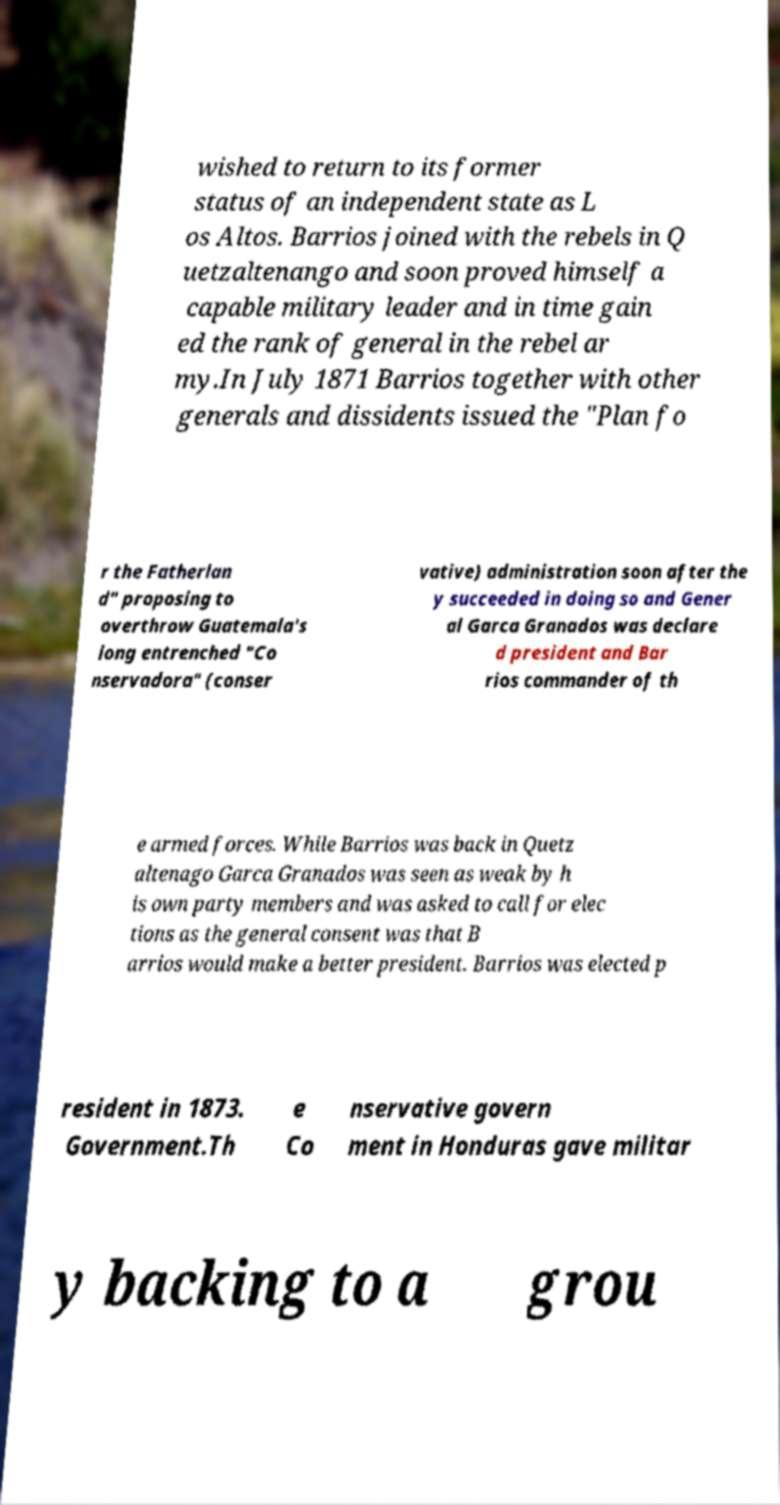Could you extract and type out the text from this image? wished to return to its former status of an independent state as L os Altos. Barrios joined with the rebels in Q uetzaltenango and soon proved himself a capable military leader and in time gain ed the rank of general in the rebel ar my.In July 1871 Barrios together with other generals and dissidents issued the "Plan fo r the Fatherlan d" proposing to overthrow Guatemala's long entrenched "Co nservadora" (conser vative) administration soon after the y succeeded in doing so and Gener al Garca Granados was declare d president and Bar rios commander of th e armed forces. While Barrios was back in Quetz altenago Garca Granados was seen as weak by h is own party members and was asked to call for elec tions as the general consent was that B arrios would make a better president. Barrios was elected p resident in 1873. Government.Th e Co nservative govern ment in Honduras gave militar y backing to a grou 